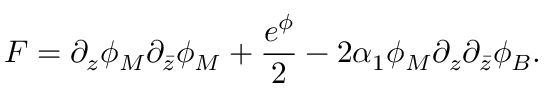<formula> <loc_0><loc_0><loc_500><loc_500>F = \partial _ { z } \phi _ { M } \partial _ { \bar { z } } \phi _ { M } + \frac { e ^ { \phi } } { 2 } - 2 \alpha _ { 1 } \phi _ { M } \partial _ { z } \partial _ { \bar { z } } \phi _ { B } .</formula> 